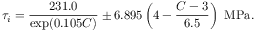<formula> <loc_0><loc_0><loc_500><loc_500>\tau _ { i } = \frac { 2 3 1 . 0 } { \exp ( 0 . 1 0 5 C ) } \pm 6 . 8 9 5 \left ( 4 - \frac { C - 3 } { 6 . 5 } \right ) \ M P a .</formula> 